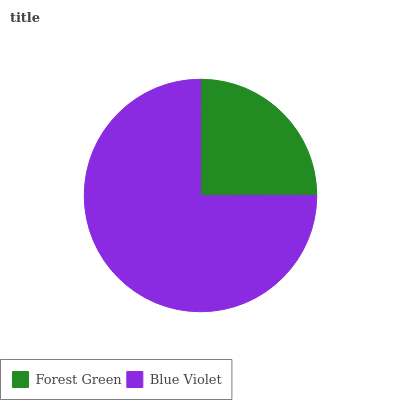Is Forest Green the minimum?
Answer yes or no. Yes. Is Blue Violet the maximum?
Answer yes or no. Yes. Is Blue Violet the minimum?
Answer yes or no. No. Is Blue Violet greater than Forest Green?
Answer yes or no. Yes. Is Forest Green less than Blue Violet?
Answer yes or no. Yes. Is Forest Green greater than Blue Violet?
Answer yes or no. No. Is Blue Violet less than Forest Green?
Answer yes or no. No. Is Blue Violet the high median?
Answer yes or no. Yes. Is Forest Green the low median?
Answer yes or no. Yes. Is Forest Green the high median?
Answer yes or no. No. Is Blue Violet the low median?
Answer yes or no. No. 